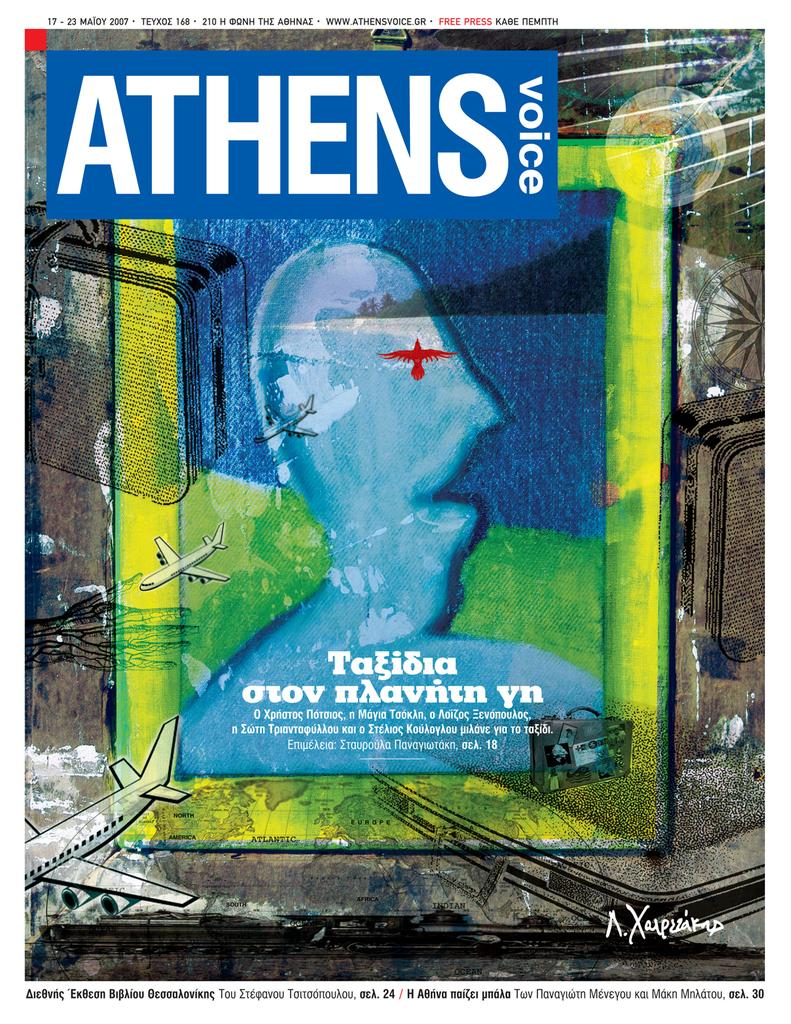<image>
Provide a brief description of the given image. A painting is on the cover of the Athens Voice magazine. 